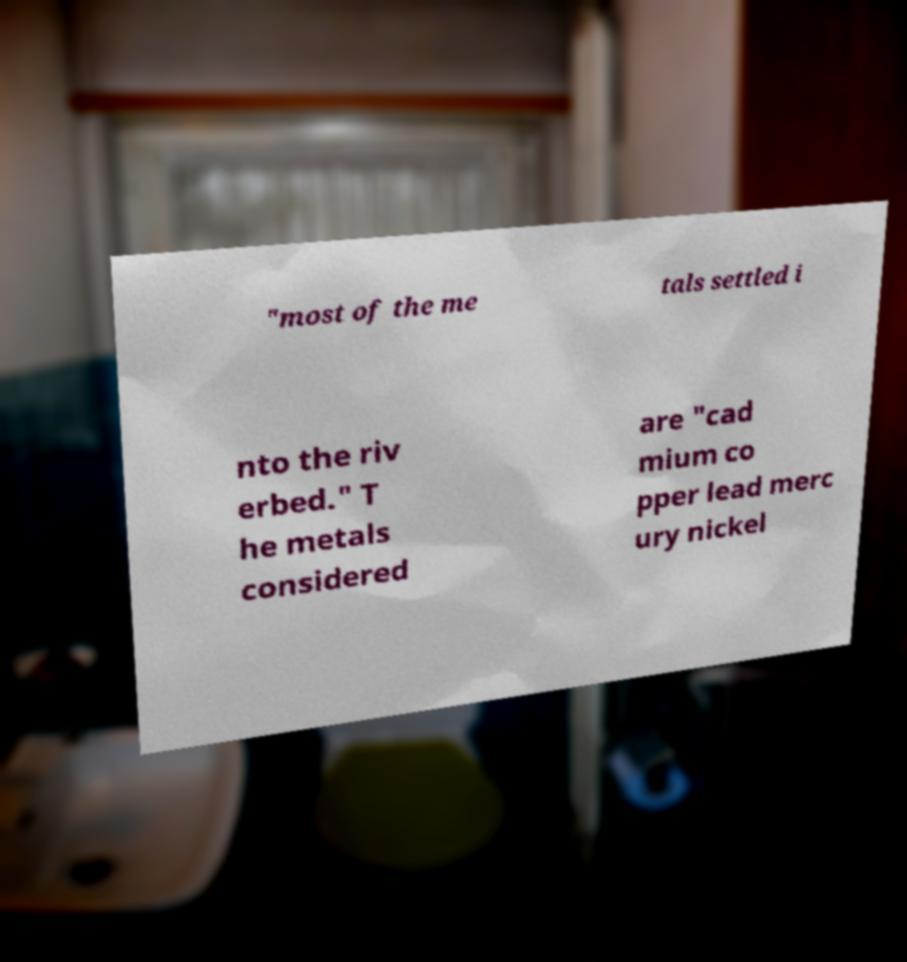There's text embedded in this image that I need extracted. Can you transcribe it verbatim? "most of the me tals settled i nto the riv erbed." T he metals considered are "cad mium co pper lead merc ury nickel 